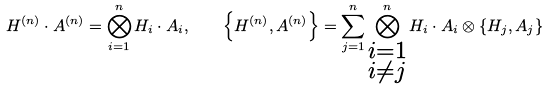<formula> <loc_0><loc_0><loc_500><loc_500>H ^ { ( n ) } \cdot A ^ { ( n ) } = \bigotimes _ { i = 1 } ^ { n } H _ { i } \cdot A _ { i } , \quad \left \{ H ^ { ( n ) } , A ^ { ( n ) } \right \} = \sum _ { j = 1 } ^ { n } \bigotimes _ { \substack { i = 1 \\ i \neq j } } ^ { n } H _ { i } \cdot A _ { i } \otimes \left \{ H _ { j } , A _ { j } \right \}</formula> 